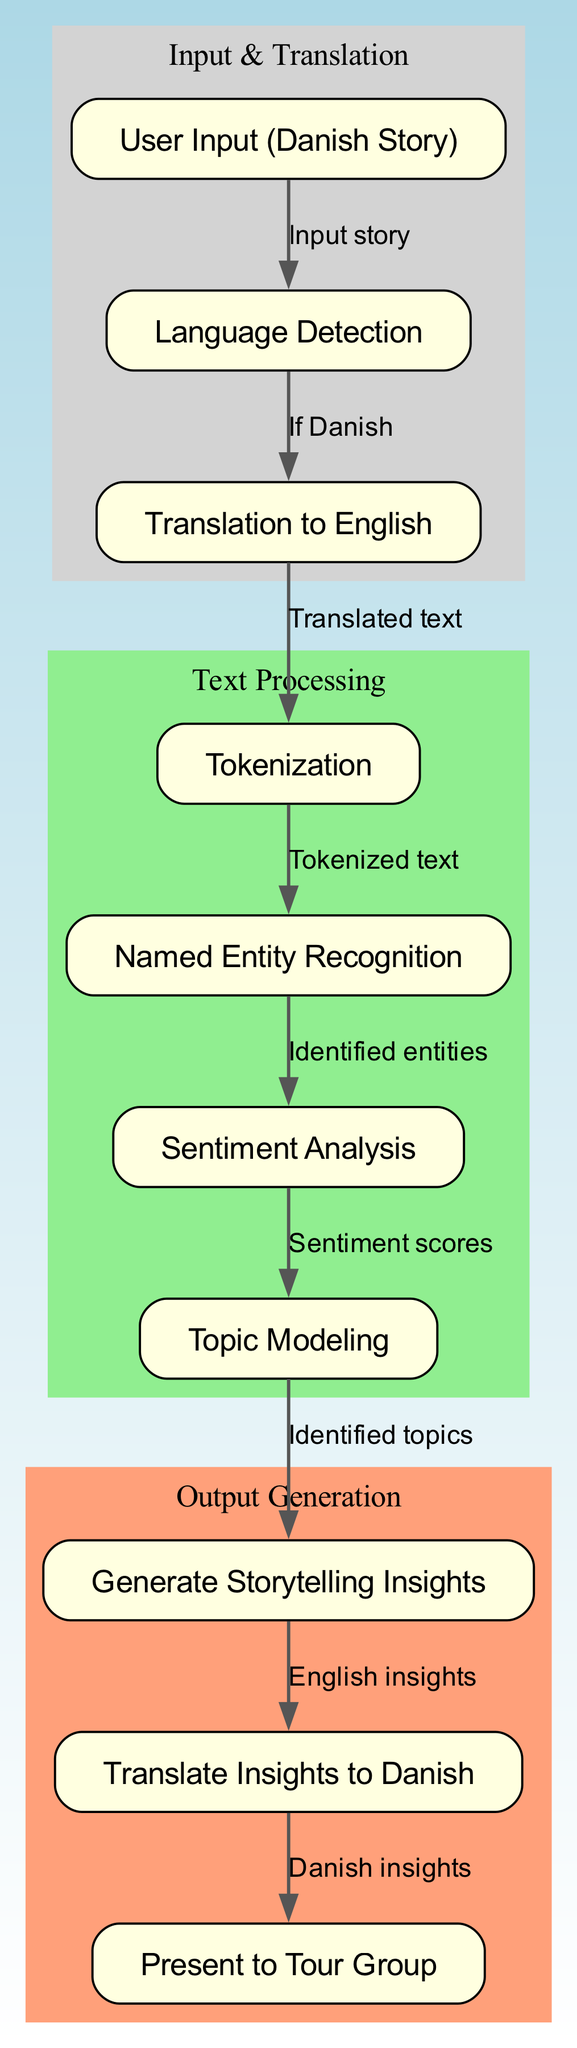What is the first node in the diagram? The diagram starts with the node labeled "User Input (Danish Story)", which is the initial step where the user provides their story.
Answer: User Input (Danish Story) How many nodes are there in total? By counting each unique node in the diagram, there are a total of ten nodes that represent different steps in the natural language processing process.
Answer: Ten What is the label of the node that follows "Translation to English"? After "Translation to English", the next node is labeled "Tokenization", which is where the translated text is processed into tokens.
Answer: Tokenization Which node is directly connected to "Sentiment Analysis"? The node directly connected to "Sentiment Analysis" is "Topic Modeling", indicating that after analyzing sentiment, the system proceeds to identify topics within the text.
Answer: Topic Modeling What happens after the "Generated Storytelling Insights"? Following the "Generated Storytelling Insights", the next step is to "Translate Insights to Danish", which implies that the insights are converted back to Danish for presentation.
Answer: Translate Insights to Danish Where does the "Language Detection" node lead to? The "Language Detection" node leads to "Translation to English" if the input is detected as Danish, indicating that translation is the next step in processing.
Answer: Translation to English What is the relationship between "Named Entity Recognition" and "Sentiment Analysis"? "Named Entity Recognition" provides the system with identified entities that are necessary for performing the subsequent step, which is "Sentiment Analysis", connecting the two processes in a sequential manner.
Answer: Identified entities What type of insights are generated in node 8? In node 8, the diagram specifies that "Generate Storytelling Insights" focuses on producing insights relevant to storytelling from the analyzed text.
Answer: Storytelling Insights Which two nodes are part of the "Output Generation" stage? The "Output Generation" stage includes the nodes "Generate Storytelling Insights" and "Present to Tour Group", as these represent the final output steps of the process before showing the results to a group.
Answer: Generate Storytelling Insights and Present to Tour Group 